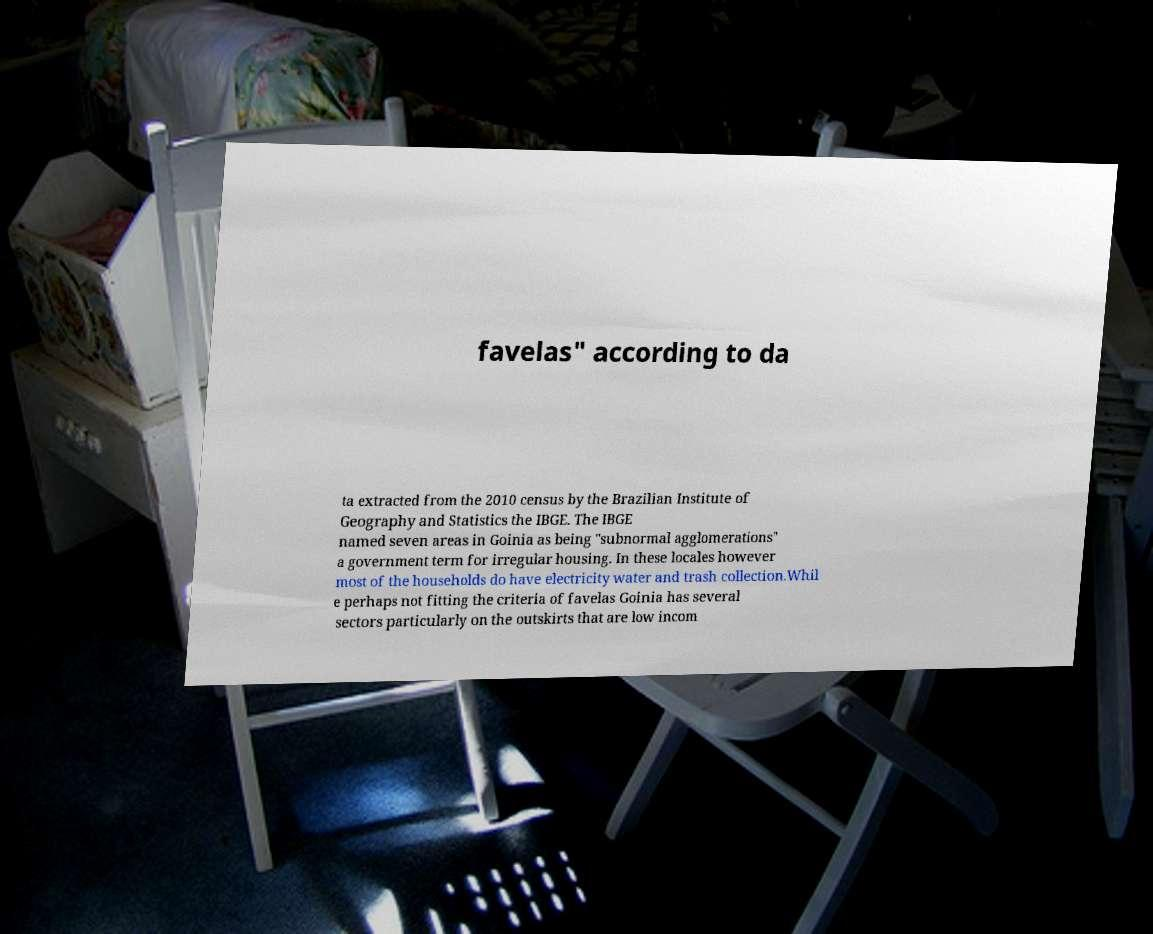Could you extract and type out the text from this image? favelas" according to da ta extracted from the 2010 census by the Brazilian Institute of Geography and Statistics the IBGE. The IBGE named seven areas in Goinia as being "subnormal agglomerations" a government term for irregular housing. In these locales however most of the households do have electricity water and trash collection.Whil e perhaps not fitting the criteria of favelas Goinia has several sectors particularly on the outskirts that are low incom 